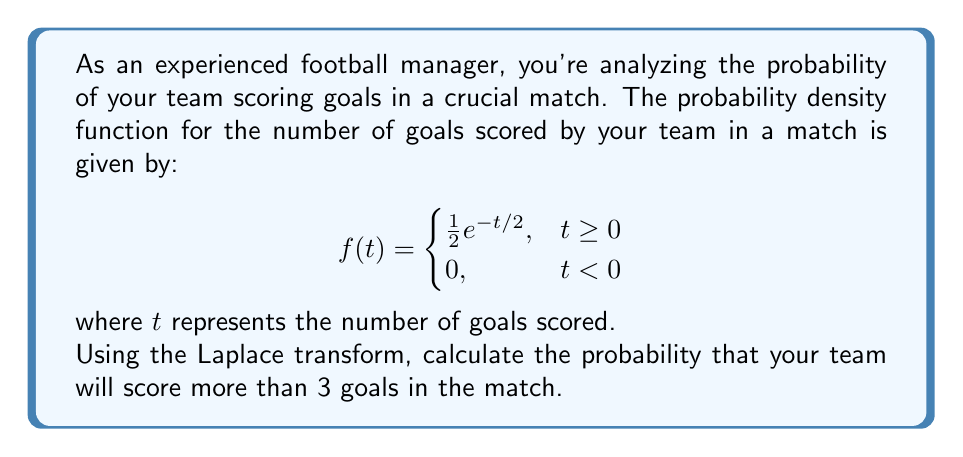Can you solve this math problem? To solve this problem, we'll follow these steps:

1) First, recall that the Laplace transform of a function $f(t)$ is defined as:

   $$\mathcal{L}\{f(t)\} = F(s) = \int_0^{\infty} e^{-st}f(t)dt$$

2) The probability of scoring more than 3 goals is:

   $$P(T > 3) = \int_3^{\infty} f(t)dt$$

3) We can express this in terms of the cumulative distribution function $F(t)$:

   $$P(T > 3) = 1 - F(3)$$

4) The cumulative distribution function is related to the Laplace transform by:

   $$F(t) = 1 - \mathcal{L}^{-1}\left\{\frac{F(s)}{s}\right\}$$

5) Let's find the Laplace transform of $f(t)$:

   $$\begin{align*}
   F(s) &= \mathcal{L}\{f(t)\} = \int_0^{\infty} e^{-st} \cdot \frac{1}{2}e^{-t/2}dt \\
   &= \frac{1}{2}\int_0^{\infty} e^{-(s+1/2)t}dt \\
   &= \frac{1}{2} \cdot \frac{1}{s+1/2} \\
   &= \frac{1}{2s+1}
   \end{align*}$$

6) Now, we need to find $\mathcal{L}^{-1}\left\{\frac{F(s)}{s}\right\}$:

   $$\mathcal{L}^{-1}\left\{\frac{F(s)}{s}\right\} = \mathcal{L}^{-1}\left\{\frac{1}{s(2s+1)}\right\}$$

7) Using partial fraction decomposition:

   $$\frac{1}{s(2s+1)} = \frac{1}{s} - \frac{2}{2s+1}$$

8) Taking the inverse Laplace transform:

   $$\mathcal{L}^{-1}\left\{\frac{1}{s(2s+1)}\right\} = 1 - e^{-t/2}$$

9) Therefore, $F(t) = 1 - (1 - e^{-t/2}) = e^{-t/2}$

10) Finally, we can calculate the probability:

    $$P(T > 3) = 1 - F(3) = 1 - e^{-3/2}$$
Answer: The probability that your team will score more than 3 goals in the match is $1 - e^{-3/2} \approx 0.7769$ or about 77.69%. 